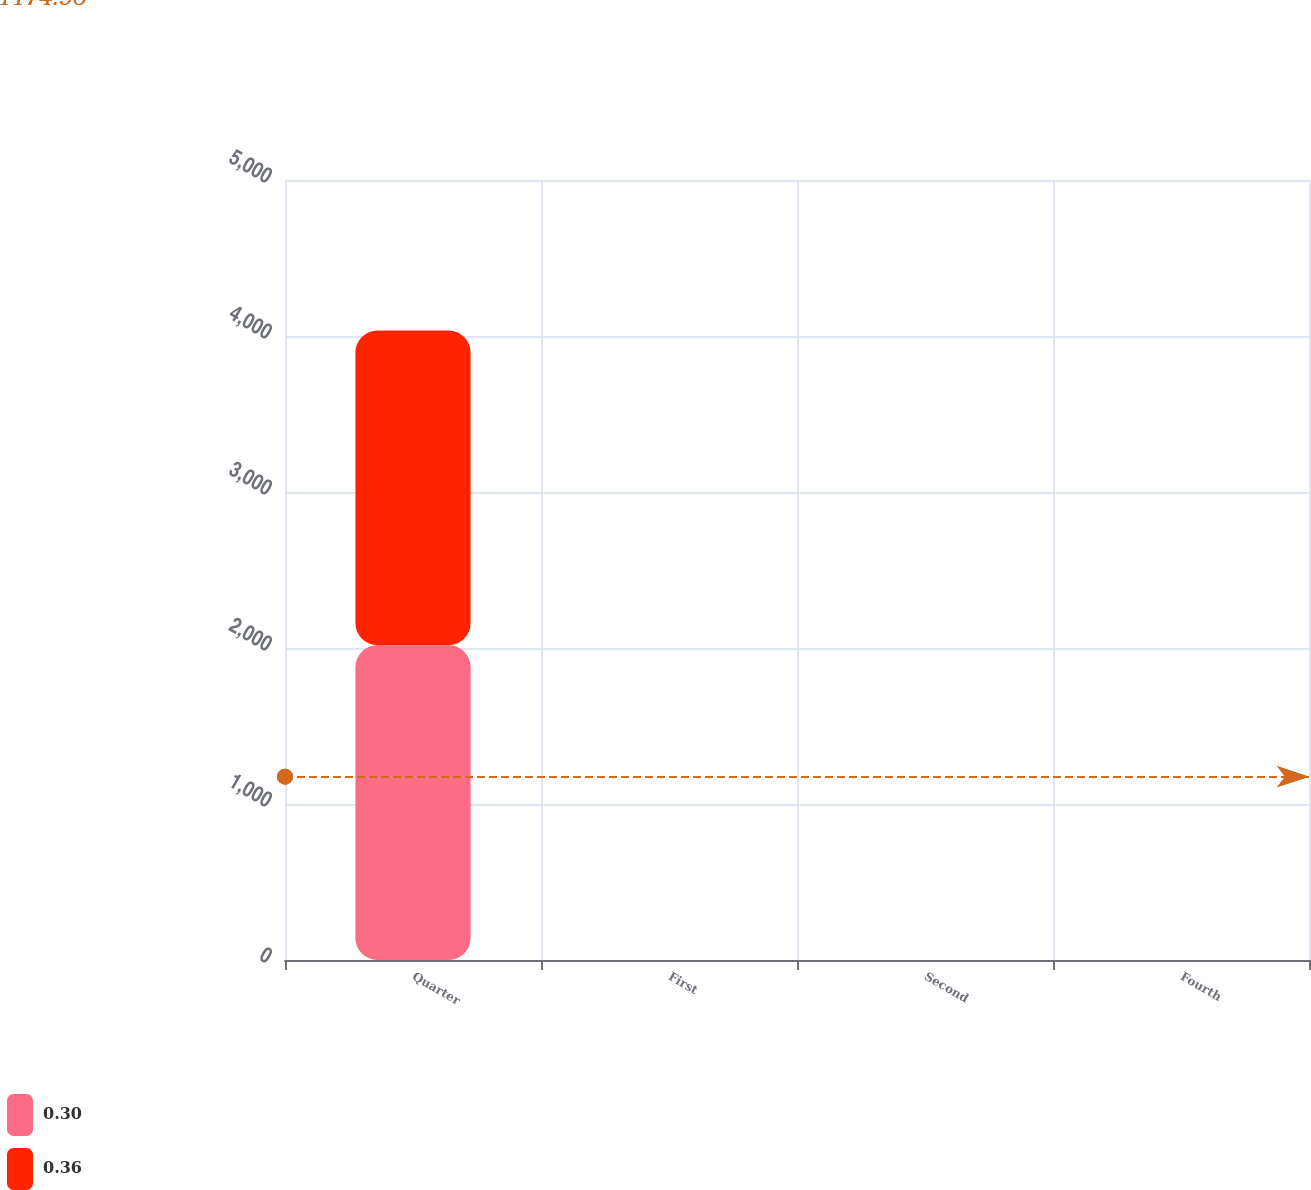<chart> <loc_0><loc_0><loc_500><loc_500><stacked_bar_chart><ecel><fcel>Quarter<fcel>First<fcel>Second<fcel>Fourth<nl><fcel>0.3<fcel>2018<fcel>0.36<fcel>0.36<fcel>0.36<nl><fcel>0.36<fcel>2017<fcel>0.3<fcel>0.3<fcel>0.3<nl></chart> 